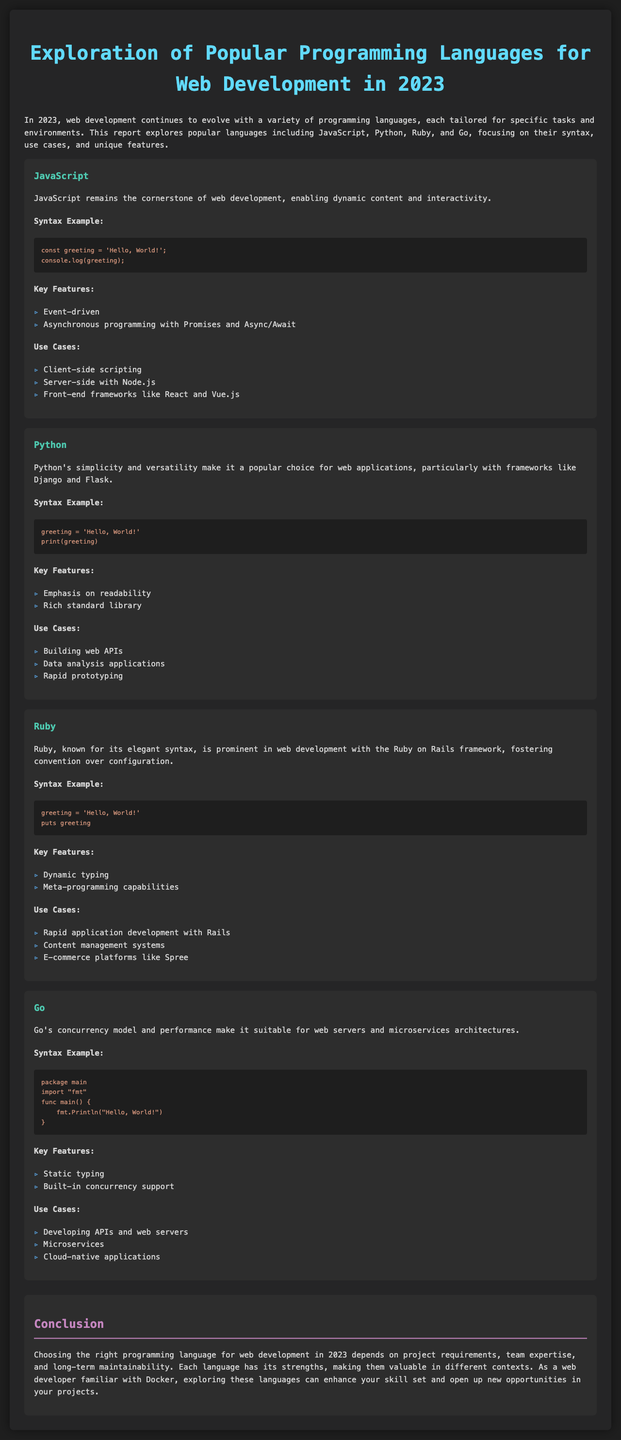What is the title of the report? The title of the report is clearly stated at the top of the document.
Answer: Exploration of Popular Programming Languages for Web Development in 2023 Which programming language is described as the cornerstone of web development? The document specifies that JavaScript is the language regarded as the cornerstone of web development.
Answer: JavaScript What is an example of Python syntax given in the report? The report includes a syntax example illustrating how to print a greeting in Python.
Answer: greeting = 'Hello, World!' print(greeting) How many programming languages are mentioned in the report? The report explicitly lists four programming languages that are explored.
Answer: Four Which language is highlighted for its elegant syntax and convention over configuration? The report attributes these characteristics to Ruby in the context of web development.
Answer: Ruby What key feature does Go provide that is notable for its performance? The report mentions built-in concurrency support as a key feature of Go.
Answer: Built-in concurrency support What use case is associated with JavaScript in the document? One of the use cases listed for JavaScript is client-side scripting, which is a critical function.
Answer: Client-side scripting What is a prominent web framework mentioned in relation to Ruby? The document specifically refers to Ruby on Rails as a prominent web framework for Ruby.
Answer: Ruby on Rails What does the conclusion emphasize about language choice? The conclusion stresses that the choice of language depends on multiple factors such as project requirements and team expertise.
Answer: Project requirements, team expertise, and long-term maintainability 